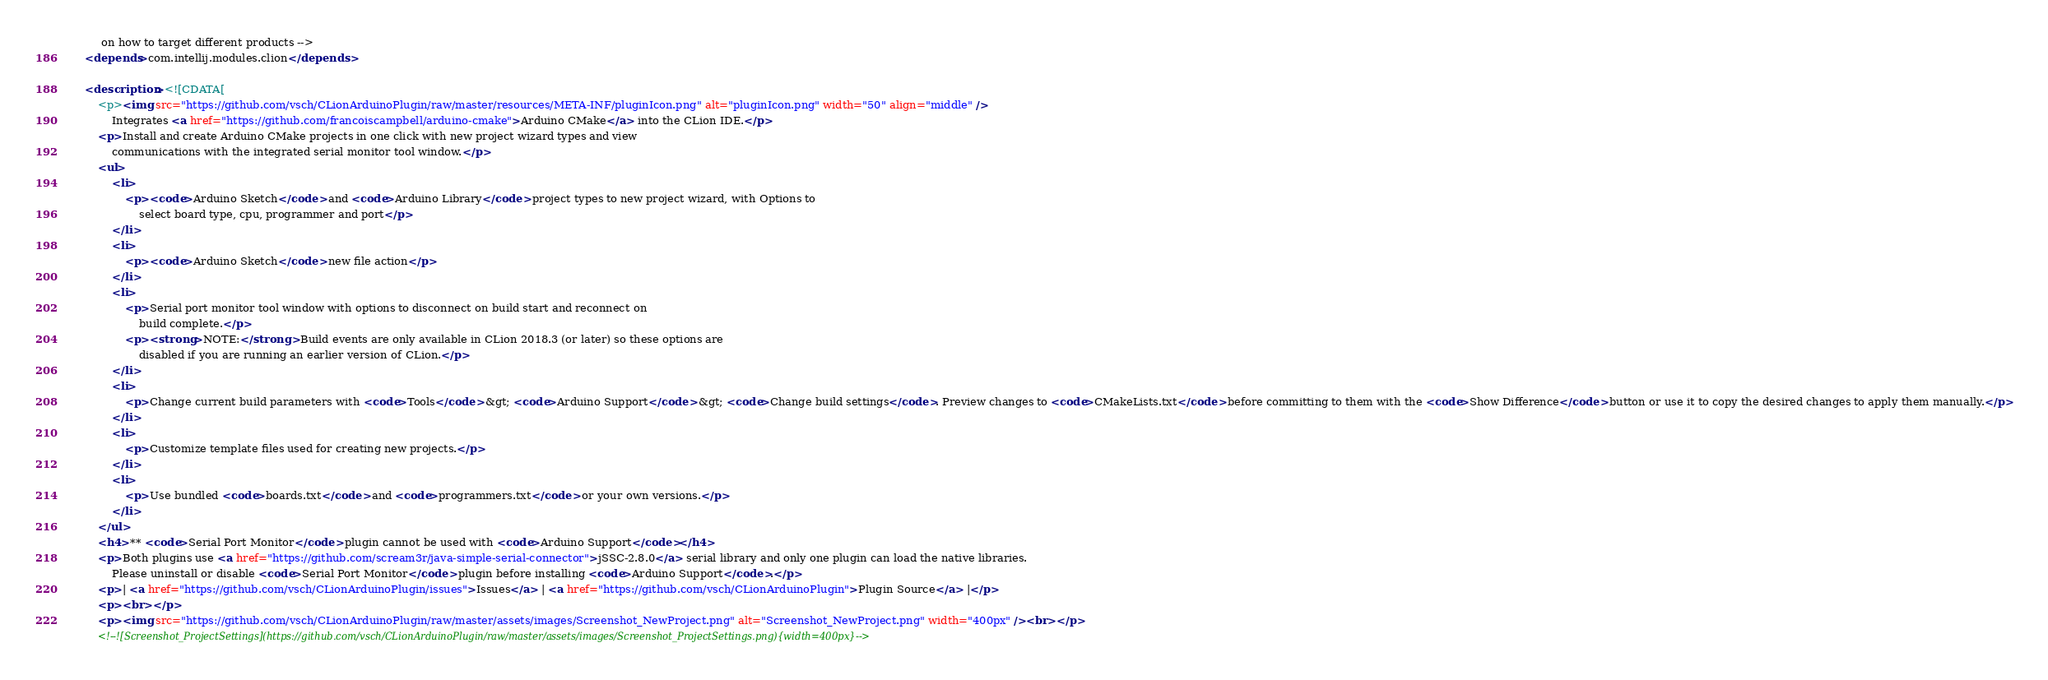<code> <loc_0><loc_0><loc_500><loc_500><_XML_>         on how to target different products -->
    <depends>com.intellij.modules.clion</depends>

    <description><![CDATA[
        <p><img src="https://github.com/vsch/CLionArduinoPlugin/raw/master/resources/META-INF/pluginIcon.png" alt="pluginIcon.png" width="50" align="middle" />
            Integrates <a href="https://github.com/francoiscampbell/arduino-cmake">Arduino CMake</a> into the CLion IDE.</p>
        <p>Install and create Arduino CMake projects in one click with new project wizard types and view
            communications with the integrated serial monitor tool window.</p>
        <ul>
            <li>
                <p><code>Arduino Sketch</code> and <code>Arduino Library</code> project types to new project wizard, with Options to
                    select board type, cpu, programmer and port</p>
            </li>
            <li>
                <p><code>Arduino Sketch</code> new file action</p>
            </li>
            <li>
                <p>Serial port monitor tool window with options to disconnect on build start and reconnect on
                    build complete.</p>
                <p><strong>NOTE:</strong> Build events are only available in CLion 2018.3 (or later) so these options are
                    disabled if you are running an earlier version of CLion.</p>
            </li>
            <li>
                <p>Change current build parameters with <code>Tools</code> &gt; <code>Arduino Support</code> &gt; <code>Change build settings</code>. Preview changes to <code>CMakeLists.txt</code> before committing to them with the <code>Show Difference</code> button or use it to copy the desired changes to apply them manually.</p>
            </li>
            <li>
                <p>Customize template files used for creating new projects.</p>
            </li>
            <li>
                <p>Use bundled <code>boards.txt</code> and <code>programmers.txt</code> or your own versions.</p>
            </li>
        </ul>
        <h4>** <code>Serial Port Monitor</code> plugin cannot be used with <code>Arduino Support</code></h4>
        <p>Both plugins use <a href="https://github.com/scream3r/java-simple-serial-connector">jSSC-2.8.0</a> serial library and only one plugin can load the native libraries.
            Please uninstall or disable <code>Serial Port Monitor</code> plugin before installing <code>Arduino Support</code>.</p>
        <p>| <a href="https://github.com/vsch/CLionArduinoPlugin/issues">Issues</a> | <a href="https://github.com/vsch/CLionArduinoPlugin">Plugin Source</a> |</p>
        <p><br></p>
        <p><img src="https://github.com/vsch/CLionArduinoPlugin/raw/master/assets/images/Screenshot_NewProject.png" alt="Screenshot_NewProject.png" width="400px" /><br></p>
        <!--![Screenshot_ProjectSettings](https://github.com/vsch/CLionArduinoPlugin/raw/master/assets/images/Screenshot_ProjectSettings.png){width=400px}--></code> 